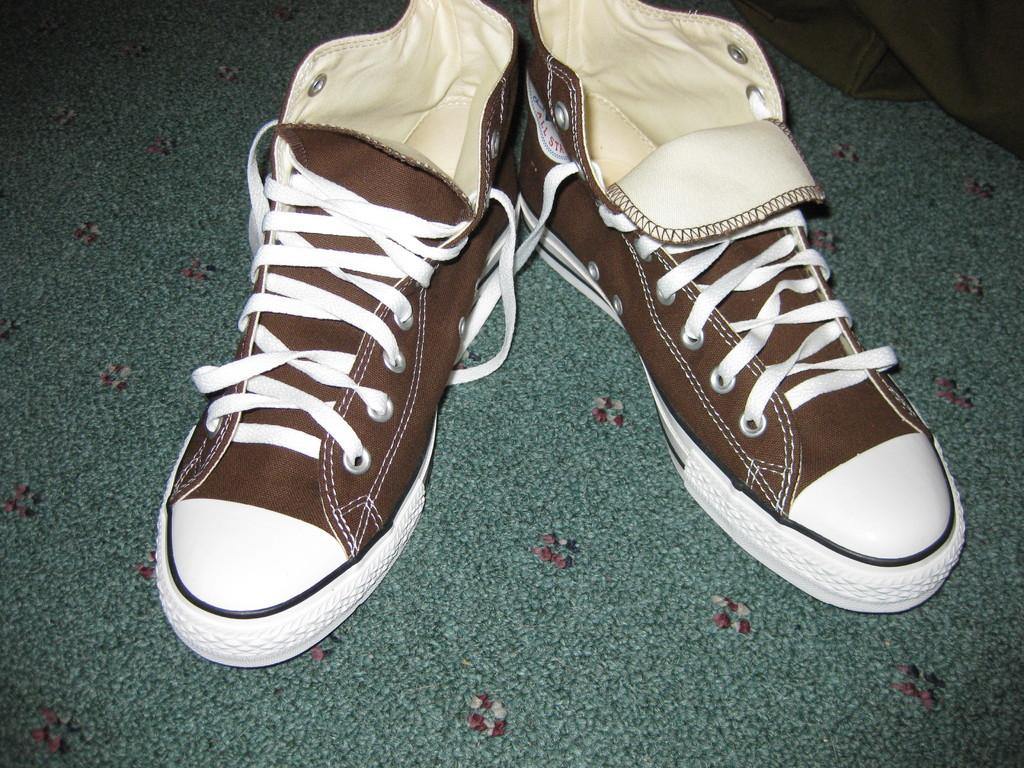What color are the shoes in the image? The shoes in the image are brown. Where are the shoes located in the image? The shoes are on the floor. What color is the mat at the bottom of the image? The mat at the bottom of the image is green. Can you describe the cloth in the top right corner of the image? The cloth in the top right corner of the image is green. What flavor does the ring have in the image? There is no ring present in the image, so it is not possible to determine its flavor. 